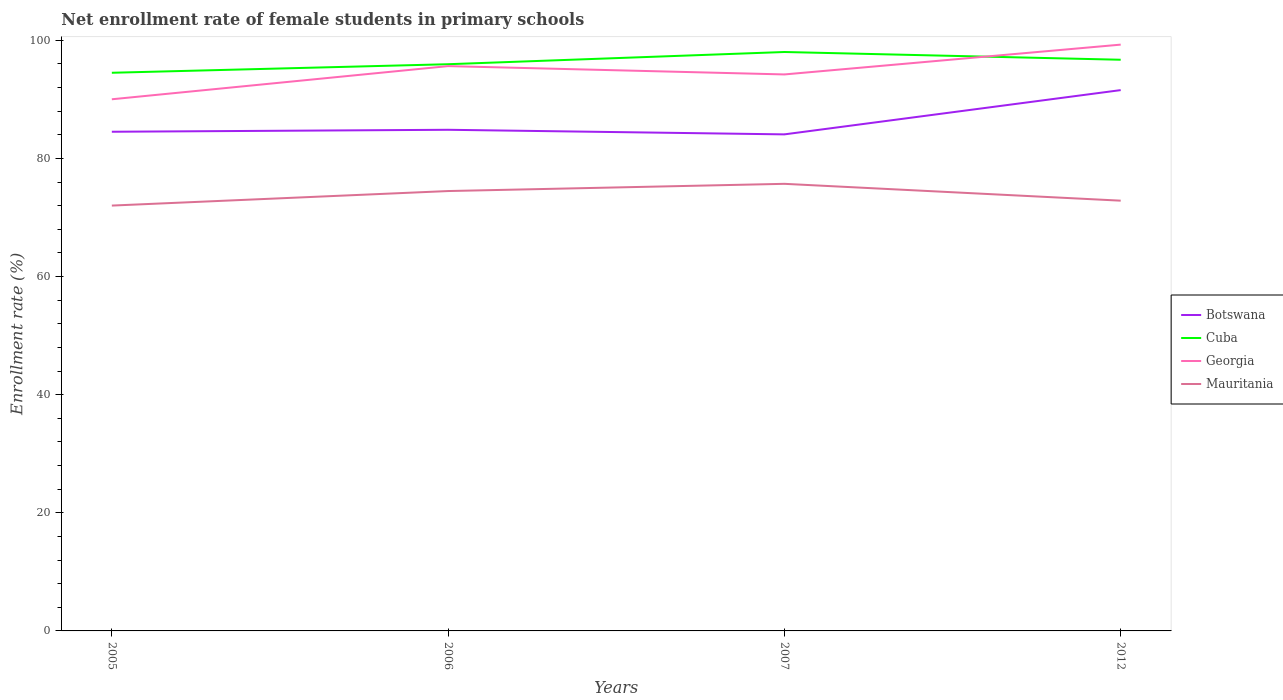Does the line corresponding to Cuba intersect with the line corresponding to Georgia?
Your answer should be very brief. Yes. Across all years, what is the maximum net enrollment rate of female students in primary schools in Georgia?
Offer a terse response. 90.02. In which year was the net enrollment rate of female students in primary schools in Cuba maximum?
Provide a short and direct response. 2005. What is the total net enrollment rate of female students in primary schools in Georgia in the graph?
Offer a terse response. -5.62. What is the difference between the highest and the second highest net enrollment rate of female students in primary schools in Mauritania?
Your response must be concise. 3.68. What is the difference between the highest and the lowest net enrollment rate of female students in primary schools in Botswana?
Keep it short and to the point. 1. Is the net enrollment rate of female students in primary schools in Botswana strictly greater than the net enrollment rate of female students in primary schools in Cuba over the years?
Your answer should be very brief. Yes. How many lines are there?
Your answer should be compact. 4. How many years are there in the graph?
Your answer should be compact. 4. What is the difference between two consecutive major ticks on the Y-axis?
Your response must be concise. 20. Are the values on the major ticks of Y-axis written in scientific E-notation?
Offer a very short reply. No. Where does the legend appear in the graph?
Your response must be concise. Center right. How are the legend labels stacked?
Provide a short and direct response. Vertical. What is the title of the graph?
Offer a very short reply. Net enrollment rate of female students in primary schools. Does "Ghana" appear as one of the legend labels in the graph?
Provide a short and direct response. No. What is the label or title of the Y-axis?
Ensure brevity in your answer.  Enrollment rate (%). What is the Enrollment rate (%) of Botswana in 2005?
Give a very brief answer. 84.52. What is the Enrollment rate (%) of Cuba in 2005?
Keep it short and to the point. 94.51. What is the Enrollment rate (%) in Georgia in 2005?
Offer a terse response. 90.02. What is the Enrollment rate (%) in Mauritania in 2005?
Make the answer very short. 72.02. What is the Enrollment rate (%) in Botswana in 2006?
Ensure brevity in your answer.  84.86. What is the Enrollment rate (%) in Cuba in 2006?
Provide a succinct answer. 95.96. What is the Enrollment rate (%) of Georgia in 2006?
Make the answer very short. 95.64. What is the Enrollment rate (%) of Mauritania in 2006?
Your response must be concise. 74.48. What is the Enrollment rate (%) of Botswana in 2007?
Your answer should be compact. 84.08. What is the Enrollment rate (%) in Cuba in 2007?
Offer a very short reply. 98.03. What is the Enrollment rate (%) of Georgia in 2007?
Offer a terse response. 94.23. What is the Enrollment rate (%) of Mauritania in 2007?
Offer a very short reply. 75.71. What is the Enrollment rate (%) of Botswana in 2012?
Offer a terse response. 91.58. What is the Enrollment rate (%) of Cuba in 2012?
Make the answer very short. 96.72. What is the Enrollment rate (%) of Georgia in 2012?
Keep it short and to the point. 99.28. What is the Enrollment rate (%) in Mauritania in 2012?
Your answer should be compact. 72.85. Across all years, what is the maximum Enrollment rate (%) of Botswana?
Offer a very short reply. 91.58. Across all years, what is the maximum Enrollment rate (%) in Cuba?
Your response must be concise. 98.03. Across all years, what is the maximum Enrollment rate (%) of Georgia?
Give a very brief answer. 99.28. Across all years, what is the maximum Enrollment rate (%) in Mauritania?
Make the answer very short. 75.71. Across all years, what is the minimum Enrollment rate (%) of Botswana?
Ensure brevity in your answer.  84.08. Across all years, what is the minimum Enrollment rate (%) of Cuba?
Give a very brief answer. 94.51. Across all years, what is the minimum Enrollment rate (%) in Georgia?
Offer a very short reply. 90.02. Across all years, what is the minimum Enrollment rate (%) of Mauritania?
Offer a terse response. 72.02. What is the total Enrollment rate (%) in Botswana in the graph?
Your answer should be compact. 345.04. What is the total Enrollment rate (%) of Cuba in the graph?
Offer a very short reply. 385.22. What is the total Enrollment rate (%) in Georgia in the graph?
Give a very brief answer. 379.17. What is the total Enrollment rate (%) in Mauritania in the graph?
Offer a very short reply. 295.07. What is the difference between the Enrollment rate (%) of Botswana in 2005 and that in 2006?
Keep it short and to the point. -0.33. What is the difference between the Enrollment rate (%) in Cuba in 2005 and that in 2006?
Offer a very short reply. -1.45. What is the difference between the Enrollment rate (%) in Georgia in 2005 and that in 2006?
Ensure brevity in your answer.  -5.62. What is the difference between the Enrollment rate (%) in Mauritania in 2005 and that in 2006?
Make the answer very short. -2.46. What is the difference between the Enrollment rate (%) in Botswana in 2005 and that in 2007?
Your response must be concise. 0.44. What is the difference between the Enrollment rate (%) in Cuba in 2005 and that in 2007?
Provide a succinct answer. -3.51. What is the difference between the Enrollment rate (%) of Georgia in 2005 and that in 2007?
Keep it short and to the point. -4.2. What is the difference between the Enrollment rate (%) of Mauritania in 2005 and that in 2007?
Your answer should be very brief. -3.68. What is the difference between the Enrollment rate (%) in Botswana in 2005 and that in 2012?
Ensure brevity in your answer.  -7.05. What is the difference between the Enrollment rate (%) of Cuba in 2005 and that in 2012?
Make the answer very short. -2.2. What is the difference between the Enrollment rate (%) of Georgia in 2005 and that in 2012?
Your answer should be compact. -9.25. What is the difference between the Enrollment rate (%) of Mauritania in 2005 and that in 2012?
Keep it short and to the point. -0.83. What is the difference between the Enrollment rate (%) in Botswana in 2006 and that in 2007?
Offer a very short reply. 0.78. What is the difference between the Enrollment rate (%) in Cuba in 2006 and that in 2007?
Offer a terse response. -2.07. What is the difference between the Enrollment rate (%) of Georgia in 2006 and that in 2007?
Provide a short and direct response. 1.41. What is the difference between the Enrollment rate (%) of Mauritania in 2006 and that in 2007?
Offer a very short reply. -1.22. What is the difference between the Enrollment rate (%) in Botswana in 2006 and that in 2012?
Provide a succinct answer. -6.72. What is the difference between the Enrollment rate (%) in Cuba in 2006 and that in 2012?
Your answer should be very brief. -0.76. What is the difference between the Enrollment rate (%) of Georgia in 2006 and that in 2012?
Your response must be concise. -3.64. What is the difference between the Enrollment rate (%) in Mauritania in 2006 and that in 2012?
Offer a terse response. 1.63. What is the difference between the Enrollment rate (%) of Botswana in 2007 and that in 2012?
Ensure brevity in your answer.  -7.49. What is the difference between the Enrollment rate (%) in Cuba in 2007 and that in 2012?
Offer a very short reply. 1.31. What is the difference between the Enrollment rate (%) of Georgia in 2007 and that in 2012?
Offer a terse response. -5.05. What is the difference between the Enrollment rate (%) of Mauritania in 2007 and that in 2012?
Offer a very short reply. 2.85. What is the difference between the Enrollment rate (%) of Botswana in 2005 and the Enrollment rate (%) of Cuba in 2006?
Keep it short and to the point. -11.44. What is the difference between the Enrollment rate (%) of Botswana in 2005 and the Enrollment rate (%) of Georgia in 2006?
Your answer should be compact. -11.12. What is the difference between the Enrollment rate (%) in Botswana in 2005 and the Enrollment rate (%) in Mauritania in 2006?
Ensure brevity in your answer.  10.04. What is the difference between the Enrollment rate (%) of Cuba in 2005 and the Enrollment rate (%) of Georgia in 2006?
Ensure brevity in your answer.  -1.13. What is the difference between the Enrollment rate (%) in Cuba in 2005 and the Enrollment rate (%) in Mauritania in 2006?
Your response must be concise. 20.03. What is the difference between the Enrollment rate (%) in Georgia in 2005 and the Enrollment rate (%) in Mauritania in 2006?
Keep it short and to the point. 15.54. What is the difference between the Enrollment rate (%) of Botswana in 2005 and the Enrollment rate (%) of Cuba in 2007?
Give a very brief answer. -13.5. What is the difference between the Enrollment rate (%) of Botswana in 2005 and the Enrollment rate (%) of Georgia in 2007?
Ensure brevity in your answer.  -9.7. What is the difference between the Enrollment rate (%) in Botswana in 2005 and the Enrollment rate (%) in Mauritania in 2007?
Keep it short and to the point. 8.82. What is the difference between the Enrollment rate (%) of Cuba in 2005 and the Enrollment rate (%) of Georgia in 2007?
Give a very brief answer. 0.28. What is the difference between the Enrollment rate (%) of Cuba in 2005 and the Enrollment rate (%) of Mauritania in 2007?
Provide a succinct answer. 18.81. What is the difference between the Enrollment rate (%) in Georgia in 2005 and the Enrollment rate (%) in Mauritania in 2007?
Provide a short and direct response. 14.32. What is the difference between the Enrollment rate (%) of Botswana in 2005 and the Enrollment rate (%) of Cuba in 2012?
Make the answer very short. -12.19. What is the difference between the Enrollment rate (%) of Botswana in 2005 and the Enrollment rate (%) of Georgia in 2012?
Keep it short and to the point. -14.75. What is the difference between the Enrollment rate (%) in Botswana in 2005 and the Enrollment rate (%) in Mauritania in 2012?
Offer a very short reply. 11.67. What is the difference between the Enrollment rate (%) in Cuba in 2005 and the Enrollment rate (%) in Georgia in 2012?
Offer a very short reply. -4.76. What is the difference between the Enrollment rate (%) in Cuba in 2005 and the Enrollment rate (%) in Mauritania in 2012?
Offer a very short reply. 21.66. What is the difference between the Enrollment rate (%) of Georgia in 2005 and the Enrollment rate (%) of Mauritania in 2012?
Provide a succinct answer. 17.17. What is the difference between the Enrollment rate (%) in Botswana in 2006 and the Enrollment rate (%) in Cuba in 2007?
Provide a short and direct response. -13.17. What is the difference between the Enrollment rate (%) of Botswana in 2006 and the Enrollment rate (%) of Georgia in 2007?
Offer a very short reply. -9.37. What is the difference between the Enrollment rate (%) of Botswana in 2006 and the Enrollment rate (%) of Mauritania in 2007?
Offer a terse response. 9.15. What is the difference between the Enrollment rate (%) of Cuba in 2006 and the Enrollment rate (%) of Georgia in 2007?
Your answer should be very brief. 1.73. What is the difference between the Enrollment rate (%) of Cuba in 2006 and the Enrollment rate (%) of Mauritania in 2007?
Provide a succinct answer. 20.25. What is the difference between the Enrollment rate (%) of Georgia in 2006 and the Enrollment rate (%) of Mauritania in 2007?
Offer a very short reply. 19.93. What is the difference between the Enrollment rate (%) in Botswana in 2006 and the Enrollment rate (%) in Cuba in 2012?
Give a very brief answer. -11.86. What is the difference between the Enrollment rate (%) of Botswana in 2006 and the Enrollment rate (%) of Georgia in 2012?
Provide a succinct answer. -14.42. What is the difference between the Enrollment rate (%) in Botswana in 2006 and the Enrollment rate (%) in Mauritania in 2012?
Your answer should be compact. 12. What is the difference between the Enrollment rate (%) of Cuba in 2006 and the Enrollment rate (%) of Georgia in 2012?
Keep it short and to the point. -3.32. What is the difference between the Enrollment rate (%) of Cuba in 2006 and the Enrollment rate (%) of Mauritania in 2012?
Your answer should be very brief. 23.11. What is the difference between the Enrollment rate (%) of Georgia in 2006 and the Enrollment rate (%) of Mauritania in 2012?
Provide a succinct answer. 22.79. What is the difference between the Enrollment rate (%) in Botswana in 2007 and the Enrollment rate (%) in Cuba in 2012?
Provide a short and direct response. -12.63. What is the difference between the Enrollment rate (%) in Botswana in 2007 and the Enrollment rate (%) in Georgia in 2012?
Ensure brevity in your answer.  -15.2. What is the difference between the Enrollment rate (%) of Botswana in 2007 and the Enrollment rate (%) of Mauritania in 2012?
Your answer should be very brief. 11.23. What is the difference between the Enrollment rate (%) of Cuba in 2007 and the Enrollment rate (%) of Georgia in 2012?
Offer a terse response. -1.25. What is the difference between the Enrollment rate (%) of Cuba in 2007 and the Enrollment rate (%) of Mauritania in 2012?
Offer a very short reply. 25.17. What is the difference between the Enrollment rate (%) of Georgia in 2007 and the Enrollment rate (%) of Mauritania in 2012?
Your response must be concise. 21.37. What is the average Enrollment rate (%) of Botswana per year?
Give a very brief answer. 86.26. What is the average Enrollment rate (%) of Cuba per year?
Offer a very short reply. 96.3. What is the average Enrollment rate (%) in Georgia per year?
Ensure brevity in your answer.  94.79. What is the average Enrollment rate (%) in Mauritania per year?
Offer a very short reply. 73.77. In the year 2005, what is the difference between the Enrollment rate (%) of Botswana and Enrollment rate (%) of Cuba?
Offer a very short reply. -9.99. In the year 2005, what is the difference between the Enrollment rate (%) of Botswana and Enrollment rate (%) of Georgia?
Your response must be concise. -5.5. In the year 2005, what is the difference between the Enrollment rate (%) of Botswana and Enrollment rate (%) of Mauritania?
Offer a very short reply. 12.5. In the year 2005, what is the difference between the Enrollment rate (%) of Cuba and Enrollment rate (%) of Georgia?
Provide a succinct answer. 4.49. In the year 2005, what is the difference between the Enrollment rate (%) in Cuba and Enrollment rate (%) in Mauritania?
Your answer should be very brief. 22.49. In the year 2005, what is the difference between the Enrollment rate (%) of Georgia and Enrollment rate (%) of Mauritania?
Offer a very short reply. 18. In the year 2006, what is the difference between the Enrollment rate (%) in Botswana and Enrollment rate (%) in Cuba?
Offer a terse response. -11.1. In the year 2006, what is the difference between the Enrollment rate (%) in Botswana and Enrollment rate (%) in Georgia?
Provide a short and direct response. -10.78. In the year 2006, what is the difference between the Enrollment rate (%) of Botswana and Enrollment rate (%) of Mauritania?
Give a very brief answer. 10.38. In the year 2006, what is the difference between the Enrollment rate (%) in Cuba and Enrollment rate (%) in Georgia?
Your answer should be compact. 0.32. In the year 2006, what is the difference between the Enrollment rate (%) of Cuba and Enrollment rate (%) of Mauritania?
Ensure brevity in your answer.  21.48. In the year 2006, what is the difference between the Enrollment rate (%) of Georgia and Enrollment rate (%) of Mauritania?
Make the answer very short. 21.16. In the year 2007, what is the difference between the Enrollment rate (%) of Botswana and Enrollment rate (%) of Cuba?
Ensure brevity in your answer.  -13.95. In the year 2007, what is the difference between the Enrollment rate (%) in Botswana and Enrollment rate (%) in Georgia?
Your response must be concise. -10.15. In the year 2007, what is the difference between the Enrollment rate (%) in Botswana and Enrollment rate (%) in Mauritania?
Offer a very short reply. 8.37. In the year 2007, what is the difference between the Enrollment rate (%) in Cuba and Enrollment rate (%) in Georgia?
Ensure brevity in your answer.  3.8. In the year 2007, what is the difference between the Enrollment rate (%) of Cuba and Enrollment rate (%) of Mauritania?
Give a very brief answer. 22.32. In the year 2007, what is the difference between the Enrollment rate (%) of Georgia and Enrollment rate (%) of Mauritania?
Your response must be concise. 18.52. In the year 2012, what is the difference between the Enrollment rate (%) in Botswana and Enrollment rate (%) in Cuba?
Ensure brevity in your answer.  -5.14. In the year 2012, what is the difference between the Enrollment rate (%) of Botswana and Enrollment rate (%) of Georgia?
Offer a terse response. -7.7. In the year 2012, what is the difference between the Enrollment rate (%) in Botswana and Enrollment rate (%) in Mauritania?
Provide a short and direct response. 18.72. In the year 2012, what is the difference between the Enrollment rate (%) of Cuba and Enrollment rate (%) of Georgia?
Offer a very short reply. -2.56. In the year 2012, what is the difference between the Enrollment rate (%) of Cuba and Enrollment rate (%) of Mauritania?
Give a very brief answer. 23.86. In the year 2012, what is the difference between the Enrollment rate (%) in Georgia and Enrollment rate (%) in Mauritania?
Make the answer very short. 26.42. What is the ratio of the Enrollment rate (%) in Cuba in 2005 to that in 2006?
Make the answer very short. 0.98. What is the ratio of the Enrollment rate (%) in Georgia in 2005 to that in 2006?
Your answer should be compact. 0.94. What is the ratio of the Enrollment rate (%) of Mauritania in 2005 to that in 2006?
Your answer should be compact. 0.97. What is the ratio of the Enrollment rate (%) of Botswana in 2005 to that in 2007?
Your answer should be compact. 1.01. What is the ratio of the Enrollment rate (%) of Cuba in 2005 to that in 2007?
Keep it short and to the point. 0.96. What is the ratio of the Enrollment rate (%) of Georgia in 2005 to that in 2007?
Offer a very short reply. 0.96. What is the ratio of the Enrollment rate (%) of Mauritania in 2005 to that in 2007?
Ensure brevity in your answer.  0.95. What is the ratio of the Enrollment rate (%) of Botswana in 2005 to that in 2012?
Make the answer very short. 0.92. What is the ratio of the Enrollment rate (%) in Cuba in 2005 to that in 2012?
Make the answer very short. 0.98. What is the ratio of the Enrollment rate (%) in Georgia in 2005 to that in 2012?
Ensure brevity in your answer.  0.91. What is the ratio of the Enrollment rate (%) in Mauritania in 2005 to that in 2012?
Give a very brief answer. 0.99. What is the ratio of the Enrollment rate (%) of Botswana in 2006 to that in 2007?
Offer a terse response. 1.01. What is the ratio of the Enrollment rate (%) in Cuba in 2006 to that in 2007?
Your answer should be compact. 0.98. What is the ratio of the Enrollment rate (%) of Mauritania in 2006 to that in 2007?
Offer a very short reply. 0.98. What is the ratio of the Enrollment rate (%) of Botswana in 2006 to that in 2012?
Ensure brevity in your answer.  0.93. What is the ratio of the Enrollment rate (%) of Georgia in 2006 to that in 2012?
Provide a succinct answer. 0.96. What is the ratio of the Enrollment rate (%) of Mauritania in 2006 to that in 2012?
Provide a short and direct response. 1.02. What is the ratio of the Enrollment rate (%) in Botswana in 2007 to that in 2012?
Your answer should be very brief. 0.92. What is the ratio of the Enrollment rate (%) of Cuba in 2007 to that in 2012?
Offer a very short reply. 1.01. What is the ratio of the Enrollment rate (%) in Georgia in 2007 to that in 2012?
Provide a succinct answer. 0.95. What is the ratio of the Enrollment rate (%) in Mauritania in 2007 to that in 2012?
Provide a short and direct response. 1.04. What is the difference between the highest and the second highest Enrollment rate (%) in Botswana?
Your answer should be very brief. 6.72. What is the difference between the highest and the second highest Enrollment rate (%) of Cuba?
Your answer should be very brief. 1.31. What is the difference between the highest and the second highest Enrollment rate (%) of Georgia?
Your response must be concise. 3.64. What is the difference between the highest and the second highest Enrollment rate (%) in Mauritania?
Keep it short and to the point. 1.22. What is the difference between the highest and the lowest Enrollment rate (%) in Botswana?
Provide a succinct answer. 7.49. What is the difference between the highest and the lowest Enrollment rate (%) of Cuba?
Ensure brevity in your answer.  3.51. What is the difference between the highest and the lowest Enrollment rate (%) of Georgia?
Offer a very short reply. 9.25. What is the difference between the highest and the lowest Enrollment rate (%) of Mauritania?
Your answer should be very brief. 3.68. 